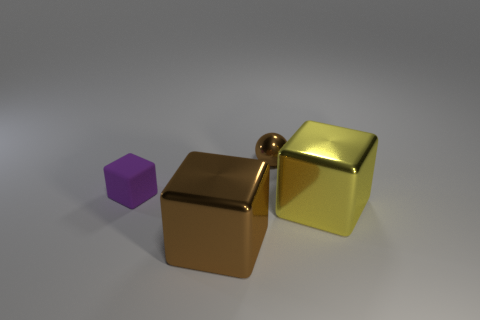Add 4 large yellow shiny cubes. How many objects exist? 8 Subtract all blocks. How many objects are left? 1 Add 3 brown metal things. How many brown metal things are left? 5 Add 3 rubber objects. How many rubber objects exist? 4 Subtract 0 gray cylinders. How many objects are left? 4 Subtract all yellow things. Subtract all large yellow metal spheres. How many objects are left? 3 